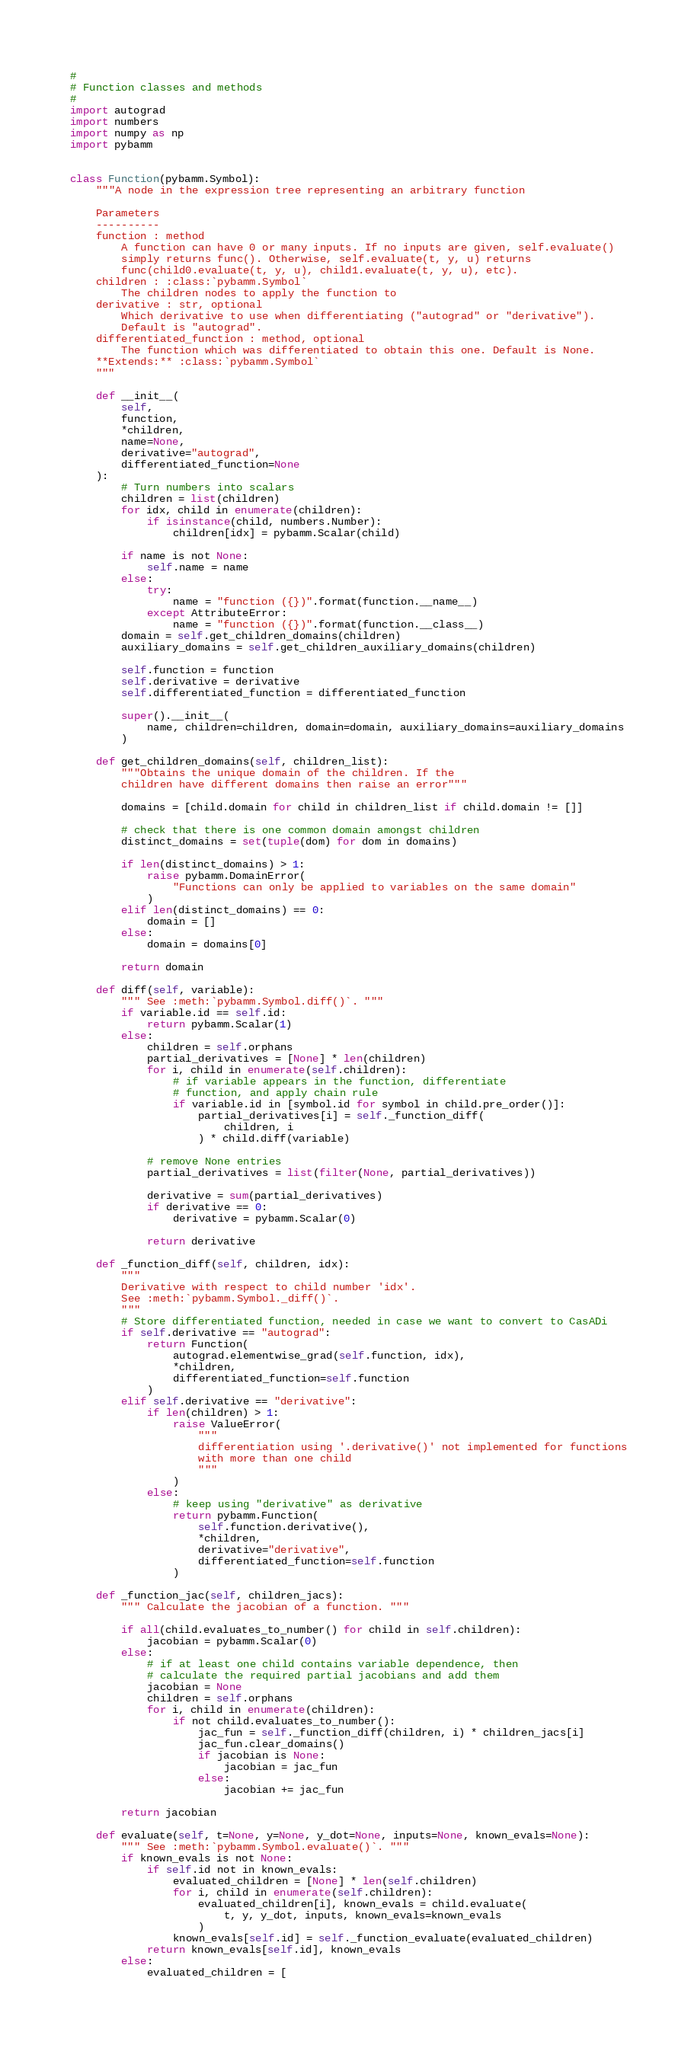Convert code to text. <code><loc_0><loc_0><loc_500><loc_500><_Python_>#
# Function classes and methods
#
import autograd
import numbers
import numpy as np
import pybamm


class Function(pybamm.Symbol):
    """A node in the expression tree representing an arbitrary function

    Parameters
    ----------
    function : method
        A function can have 0 or many inputs. If no inputs are given, self.evaluate()
        simply returns func(). Otherwise, self.evaluate(t, y, u) returns
        func(child0.evaluate(t, y, u), child1.evaluate(t, y, u), etc).
    children : :class:`pybamm.Symbol`
        The children nodes to apply the function to
    derivative : str, optional
        Which derivative to use when differentiating ("autograd" or "derivative").
        Default is "autograd".
    differentiated_function : method, optional
        The function which was differentiated to obtain this one. Default is None.
    **Extends:** :class:`pybamm.Symbol`
    """

    def __init__(
        self,
        function,
        *children,
        name=None,
        derivative="autograd",
        differentiated_function=None
    ):
        # Turn numbers into scalars
        children = list(children)
        for idx, child in enumerate(children):
            if isinstance(child, numbers.Number):
                children[idx] = pybamm.Scalar(child)

        if name is not None:
            self.name = name
        else:
            try:
                name = "function ({})".format(function.__name__)
            except AttributeError:
                name = "function ({})".format(function.__class__)
        domain = self.get_children_domains(children)
        auxiliary_domains = self.get_children_auxiliary_domains(children)

        self.function = function
        self.derivative = derivative
        self.differentiated_function = differentiated_function

        super().__init__(
            name, children=children, domain=domain, auxiliary_domains=auxiliary_domains
        )

    def get_children_domains(self, children_list):
        """Obtains the unique domain of the children. If the
        children have different domains then raise an error"""

        domains = [child.domain for child in children_list if child.domain != []]

        # check that there is one common domain amongst children
        distinct_domains = set(tuple(dom) for dom in domains)

        if len(distinct_domains) > 1:
            raise pybamm.DomainError(
                "Functions can only be applied to variables on the same domain"
            )
        elif len(distinct_domains) == 0:
            domain = []
        else:
            domain = domains[0]

        return domain

    def diff(self, variable):
        """ See :meth:`pybamm.Symbol.diff()`. """
        if variable.id == self.id:
            return pybamm.Scalar(1)
        else:
            children = self.orphans
            partial_derivatives = [None] * len(children)
            for i, child in enumerate(self.children):
                # if variable appears in the function, differentiate
                # function, and apply chain rule
                if variable.id in [symbol.id for symbol in child.pre_order()]:
                    partial_derivatives[i] = self._function_diff(
                        children, i
                    ) * child.diff(variable)

            # remove None entries
            partial_derivatives = list(filter(None, partial_derivatives))

            derivative = sum(partial_derivatives)
            if derivative == 0:
                derivative = pybamm.Scalar(0)

            return derivative

    def _function_diff(self, children, idx):
        """
        Derivative with respect to child number 'idx'.
        See :meth:`pybamm.Symbol._diff()`.
        """
        # Store differentiated function, needed in case we want to convert to CasADi
        if self.derivative == "autograd":
            return Function(
                autograd.elementwise_grad(self.function, idx),
                *children,
                differentiated_function=self.function
            )
        elif self.derivative == "derivative":
            if len(children) > 1:
                raise ValueError(
                    """
                    differentiation using '.derivative()' not implemented for functions
                    with more than one child
                    """
                )
            else:
                # keep using "derivative" as derivative
                return pybamm.Function(
                    self.function.derivative(),
                    *children,
                    derivative="derivative",
                    differentiated_function=self.function
                )

    def _function_jac(self, children_jacs):
        """ Calculate the jacobian of a function. """

        if all(child.evaluates_to_number() for child in self.children):
            jacobian = pybamm.Scalar(0)
        else:
            # if at least one child contains variable dependence, then
            # calculate the required partial jacobians and add them
            jacobian = None
            children = self.orphans
            for i, child in enumerate(children):
                if not child.evaluates_to_number():
                    jac_fun = self._function_diff(children, i) * children_jacs[i]
                    jac_fun.clear_domains()
                    if jacobian is None:
                        jacobian = jac_fun
                    else:
                        jacobian += jac_fun

        return jacobian

    def evaluate(self, t=None, y=None, y_dot=None, inputs=None, known_evals=None):
        """ See :meth:`pybamm.Symbol.evaluate()`. """
        if known_evals is not None:
            if self.id not in known_evals:
                evaluated_children = [None] * len(self.children)
                for i, child in enumerate(self.children):
                    evaluated_children[i], known_evals = child.evaluate(
                        t, y, y_dot, inputs, known_evals=known_evals
                    )
                known_evals[self.id] = self._function_evaluate(evaluated_children)
            return known_evals[self.id], known_evals
        else:
            evaluated_children = [</code> 